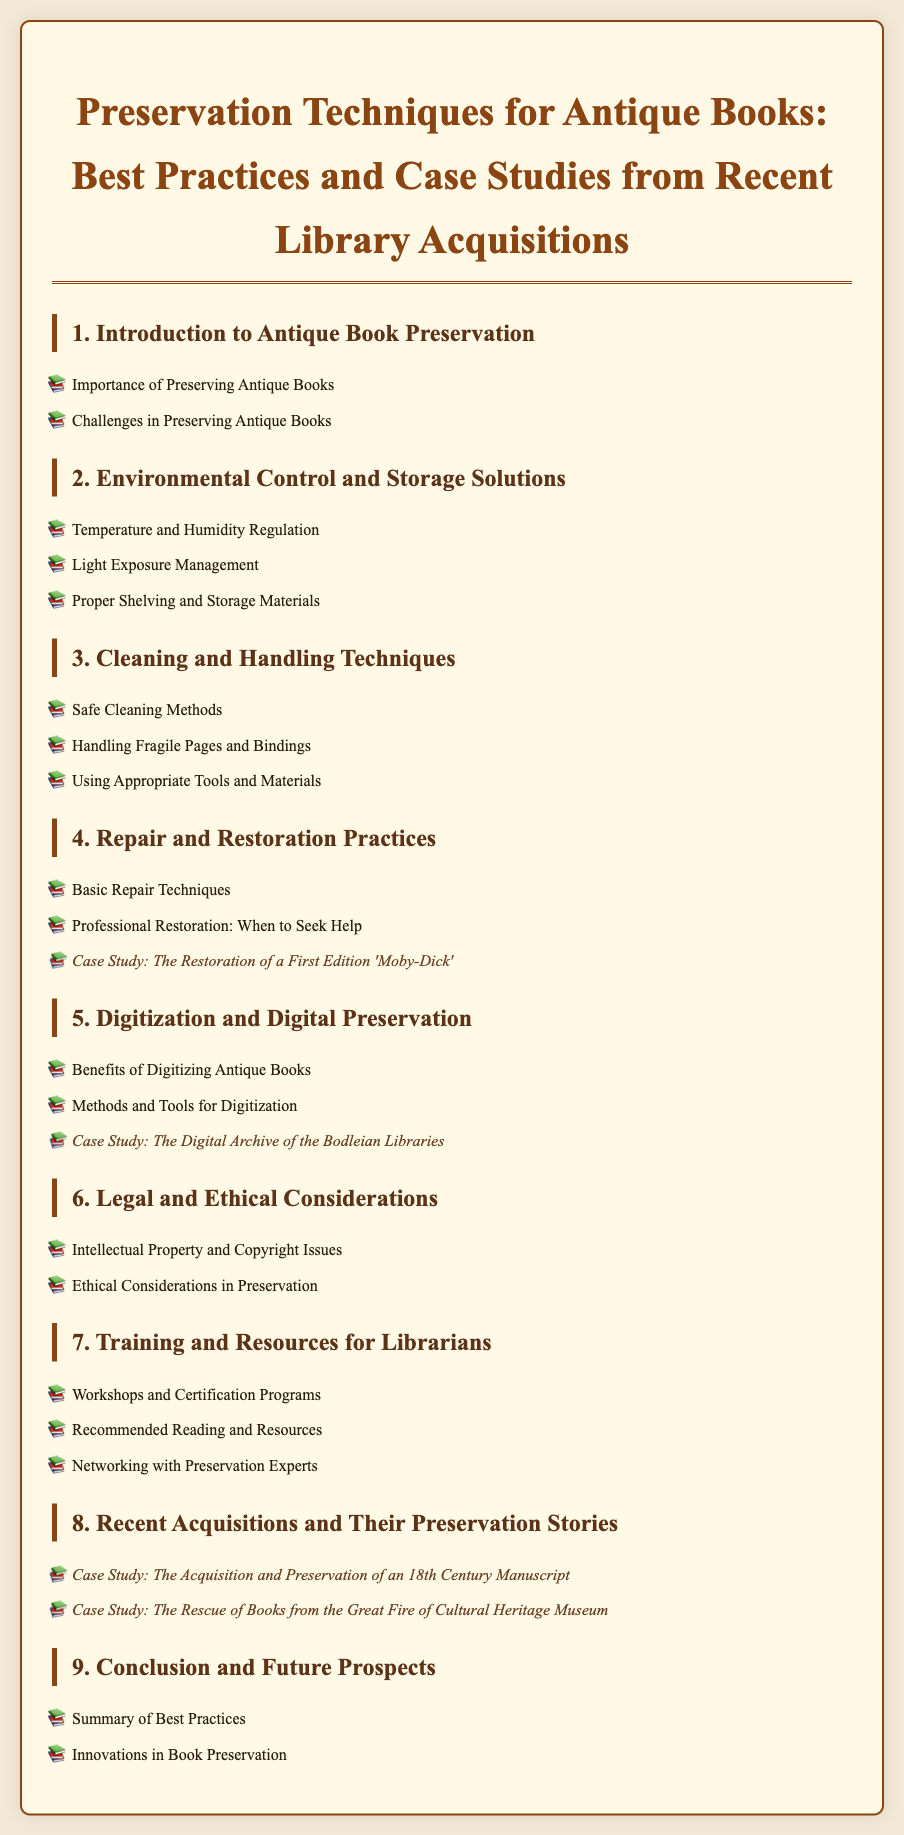What is the title of the document? The title is presented at the top of the document, describing the focus on preservation techniques.
Answer: Preservation Techniques for Antique Books: Best Practices and Case Studies from Recent Library Acquisitions How many sections are there in the document? The sections are identified as different numbered headings under the main title, a total of nine sections listed.
Answer: 9 What is the first case study mentioned in the document? The case studies are listed in the respective sections, the first one appears in section 4 under Repair and Restoration Practices.
Answer: The Restoration of a First Edition 'Moby-Dick' What is the main focus of section 6? Section 6 is dedicated to highlighting key considerations in relation to legal and ethical aspects of preservation.
Answer: Legal and Ethical Considerations Which section discusses the benefits of digitizing antique books? The benefits of digitization are specifically addressed in section 5, which focuses on this topic.
Answer: Digitization and Digital Preservation What is the title of the last section in the document? The last section summarizes important insights and future thinks for preservation practices, listed as the ninth section.
Answer: Conclusion and Future Prospects 